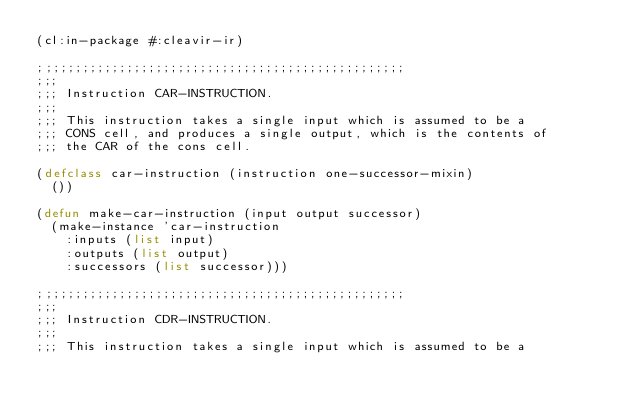<code> <loc_0><loc_0><loc_500><loc_500><_Lisp_>(cl:in-package #:cleavir-ir)

;;;;;;;;;;;;;;;;;;;;;;;;;;;;;;;;;;;;;;;;;;;;;;;;;;
;;;
;;; Instruction CAR-INSTRUCTION.
;;;
;;; This instruction takes a single input which is assumed to be a
;;; CONS cell, and produces a single output, which is the contents of
;;; the CAR of the cons cell.

(defclass car-instruction (instruction one-successor-mixin)
  ())

(defun make-car-instruction (input output successor)
  (make-instance 'car-instruction
    :inputs (list input)
    :outputs (list output)
    :successors (list successor)))

;;;;;;;;;;;;;;;;;;;;;;;;;;;;;;;;;;;;;;;;;;;;;;;;;;
;;;
;;; Instruction CDR-INSTRUCTION.
;;;
;;; This instruction takes a single input which is assumed to be a</code> 